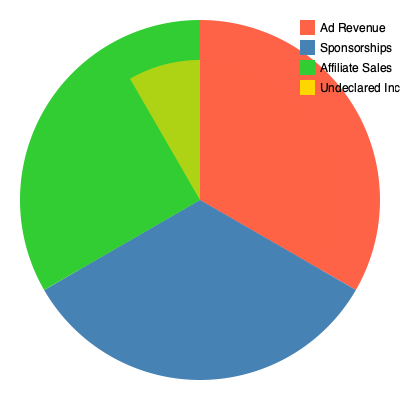Based on the pie chart comparing a blogger's declared income sources to observed revenue streams, calculate the percentage of undeclared income relative to the total observed revenue. Round your answer to the nearest whole percent. To calculate the percentage of undeclared income relative to the total observed revenue, we need to follow these steps:

1. Identify the undeclared income:
   The yellow slice in the inner circle represents undeclared income.

2. Estimate the proportion of undeclared income:
   The yellow slice appears to cover about 1/8 of the inner circle.

3. Calculate the percentage:
   $\frac{1}{8} \times 100\% = 12.5\%$

4. Round to the nearest whole percent:
   12.5% rounds to 13%

Therefore, the undeclared income represents approximately 13% of the total observed revenue.

This discrepancy between declared income and observed revenue is significant from a tax inspector's perspective, as it suggests potential tax evasion or underreporting of income by the blogger.
Answer: 13% 